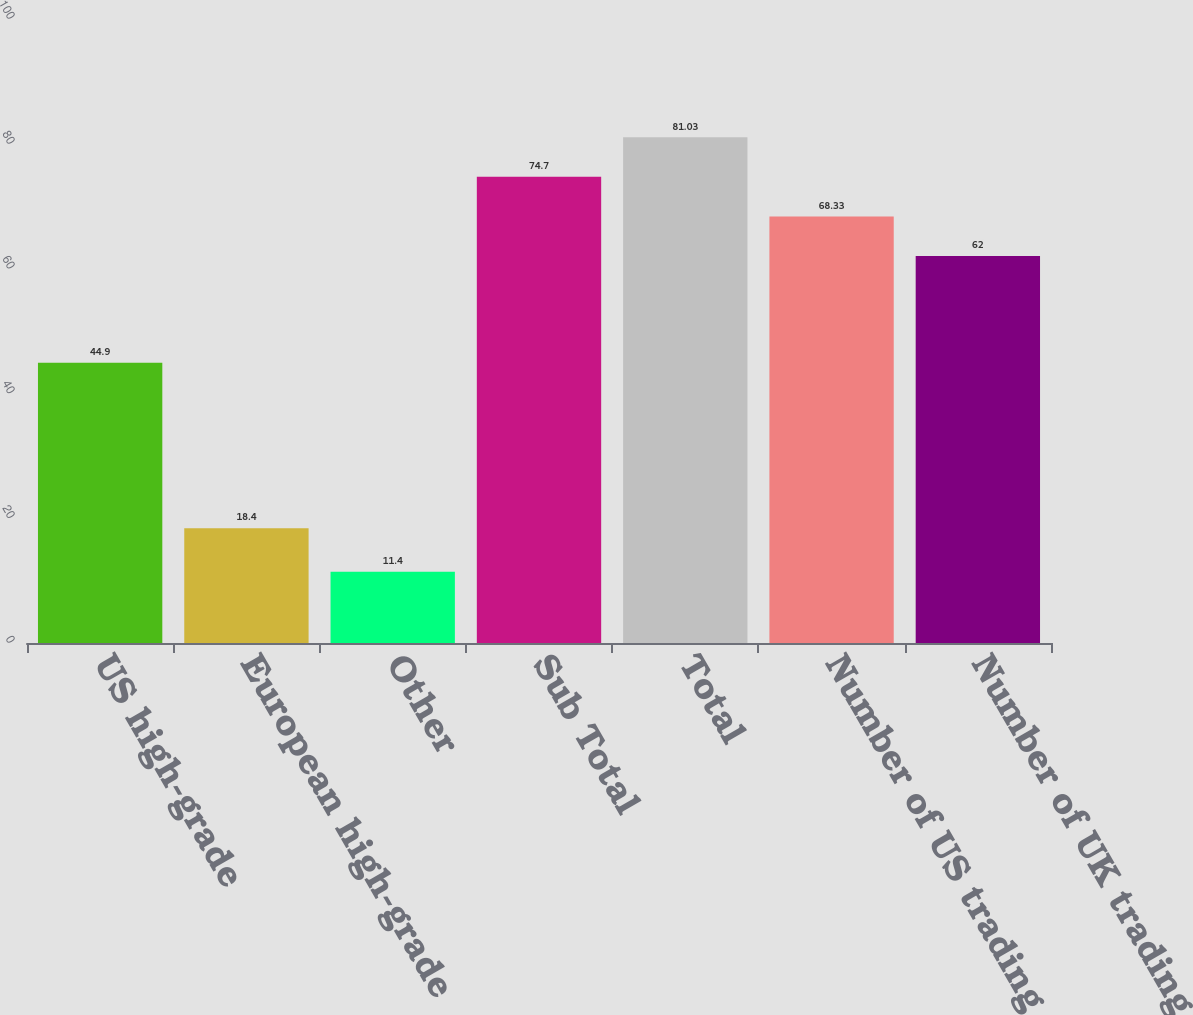Convert chart. <chart><loc_0><loc_0><loc_500><loc_500><bar_chart><fcel>US high-grade<fcel>European high-grade<fcel>Other<fcel>Sub Total<fcel>Total<fcel>Number of US trading days<fcel>Number of UK trading days<nl><fcel>44.9<fcel>18.4<fcel>11.4<fcel>74.7<fcel>81.03<fcel>68.33<fcel>62<nl></chart> 